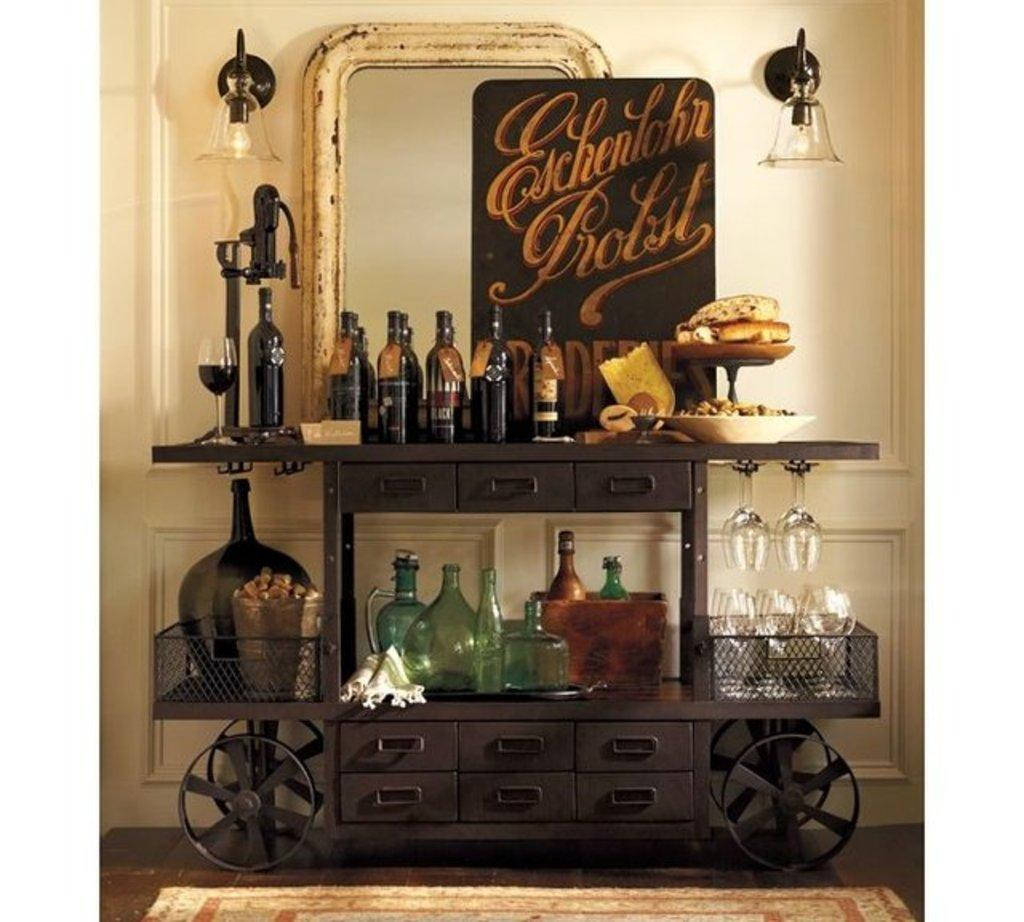<image>
Offer a succinct explanation of the picture presented. A bar and wine cart with a sign behind that reads Eschenlohr Probst 